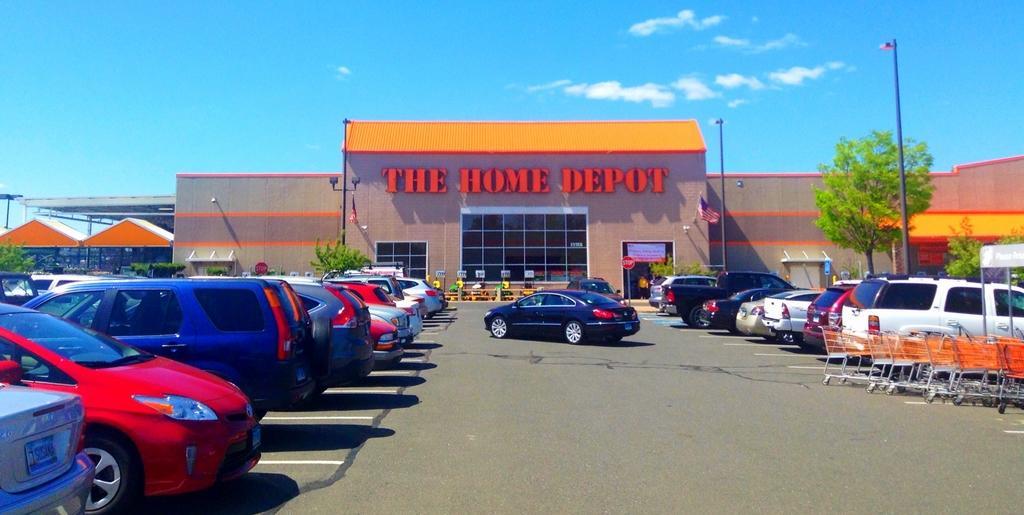Could you give a brief overview of what you see in this image? In this image I can see number of vehicles, few trolleys, few trees, a building, few boards, few poles, a flag and in the background I can see clouds and the sky. I can also see something is written over here. 